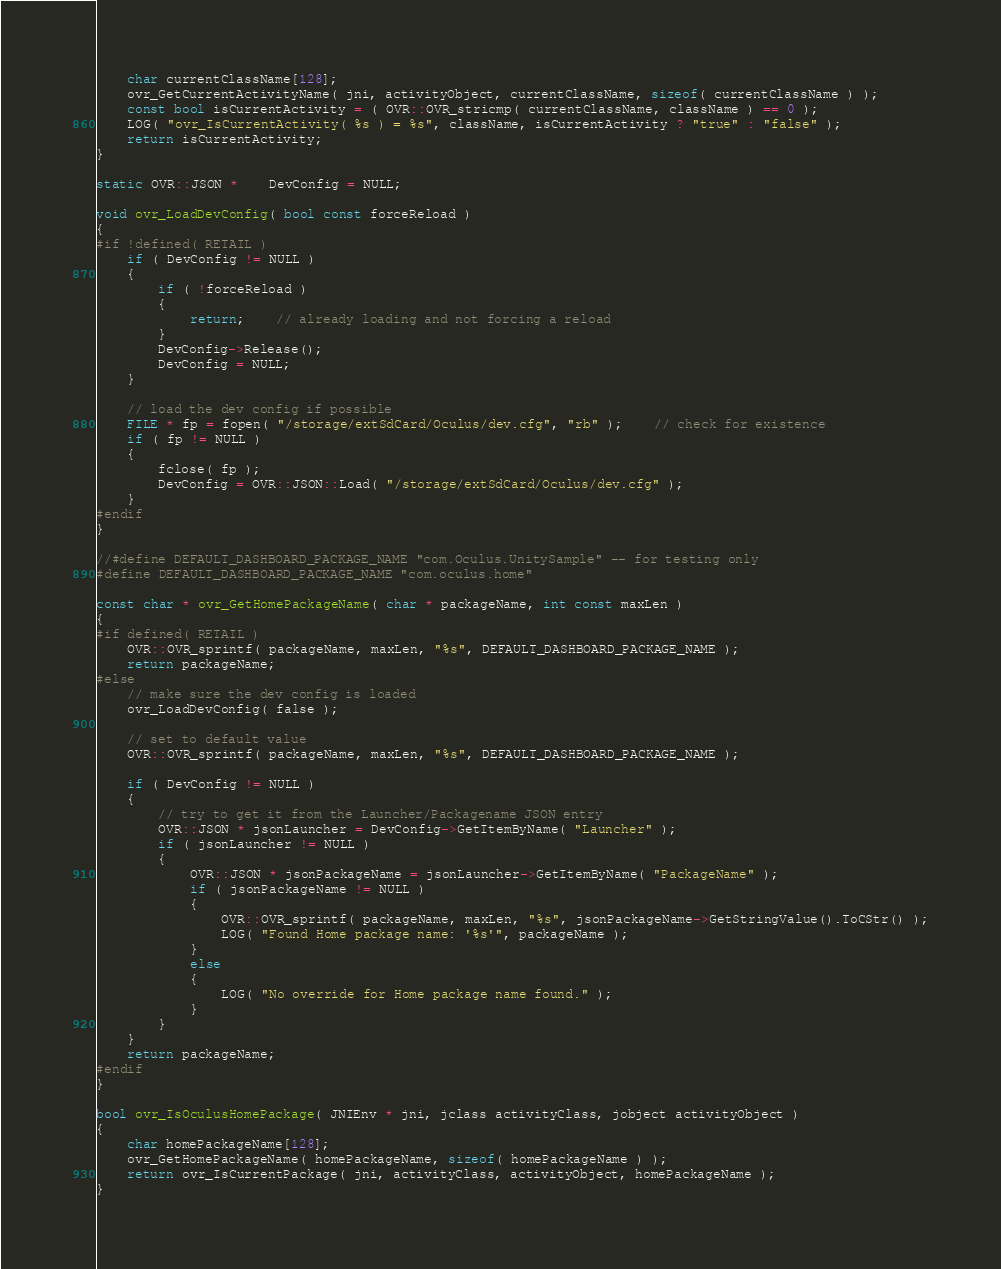<code> <loc_0><loc_0><loc_500><loc_500><_C++_>	char currentClassName[128];
	ovr_GetCurrentActivityName( jni, activityObject, currentClassName, sizeof( currentClassName ) );
	const bool isCurrentActivity = ( OVR::OVR_stricmp( currentClassName, className ) == 0 );
	LOG( "ovr_IsCurrentActivity( %s ) = %s", className, isCurrentActivity ? "true" : "false" );
	return isCurrentActivity;
}

static OVR::JSON *	DevConfig = NULL;

void ovr_LoadDevConfig( bool const forceReload )
{
#if !defined( RETAIL )
	if ( DevConfig != NULL )
	{
		if ( !forceReload )
		{
			return;	// already loading and not forcing a reload
		}
		DevConfig->Release();
		DevConfig = NULL;
	}

	// load the dev config if possible
	FILE * fp = fopen( "/storage/extSdCard/Oculus/dev.cfg", "rb" );	// check for existence
	if ( fp != NULL )
	{
		fclose( fp );
		DevConfig = OVR::JSON::Load( "/storage/extSdCard/Oculus/dev.cfg" );
	}
#endif
}

//#define DEFAULT_DASHBOARD_PACKAGE_NAME "com.Oculus.UnitySample" -- for testing only
#define DEFAULT_DASHBOARD_PACKAGE_NAME "com.oculus.home"

const char * ovr_GetHomePackageName( char * packageName, int const maxLen )
{
#if defined( RETAIL )
	OVR::OVR_sprintf( packageName, maxLen, "%s", DEFAULT_DASHBOARD_PACKAGE_NAME );
	return packageName;
#else
	// make sure the dev config is loaded
	ovr_LoadDevConfig( false );

	// set to default value
	OVR::OVR_sprintf( packageName, maxLen, "%s", DEFAULT_DASHBOARD_PACKAGE_NAME );

	if ( DevConfig != NULL )
	{
		// try to get it from the Launcher/Packagename JSON entry
		OVR::JSON * jsonLauncher = DevConfig->GetItemByName( "Launcher" );
		if ( jsonLauncher != NULL ) 
		{
			OVR::JSON * jsonPackageName = jsonLauncher->GetItemByName( "PackageName" );
			if ( jsonPackageName != NULL )
			{
				OVR::OVR_sprintf( packageName, maxLen, "%s", jsonPackageName->GetStringValue().ToCStr() );
				LOG( "Found Home package name: '%s'", packageName );
			}
			else
			{
				LOG( "No override for Home package name found." );
			}
		}
	}
	return packageName;
#endif
}

bool ovr_IsOculusHomePackage( JNIEnv * jni, jclass activityClass, jobject activityObject )
{
	char homePackageName[128];
	ovr_GetHomePackageName( homePackageName, sizeof( homePackageName ) );
	return ovr_IsCurrentPackage( jni, activityClass, activityObject, homePackageName );
}
</code> 